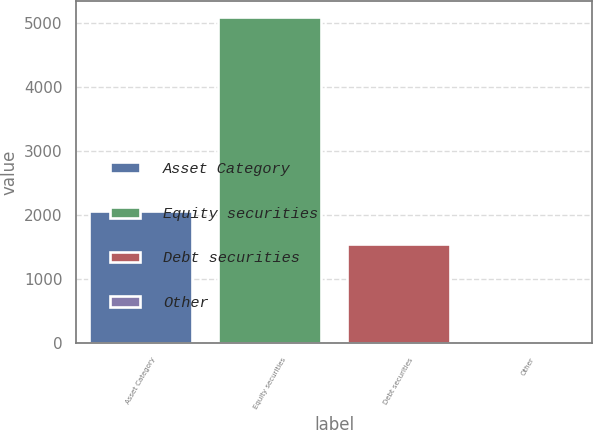Convert chart to OTSL. <chart><loc_0><loc_0><loc_500><loc_500><bar_chart><fcel>Asset Category<fcel>Equity securities<fcel>Debt securities<fcel>Other<nl><fcel>2058<fcel>5085<fcel>1550<fcel>5<nl></chart> 